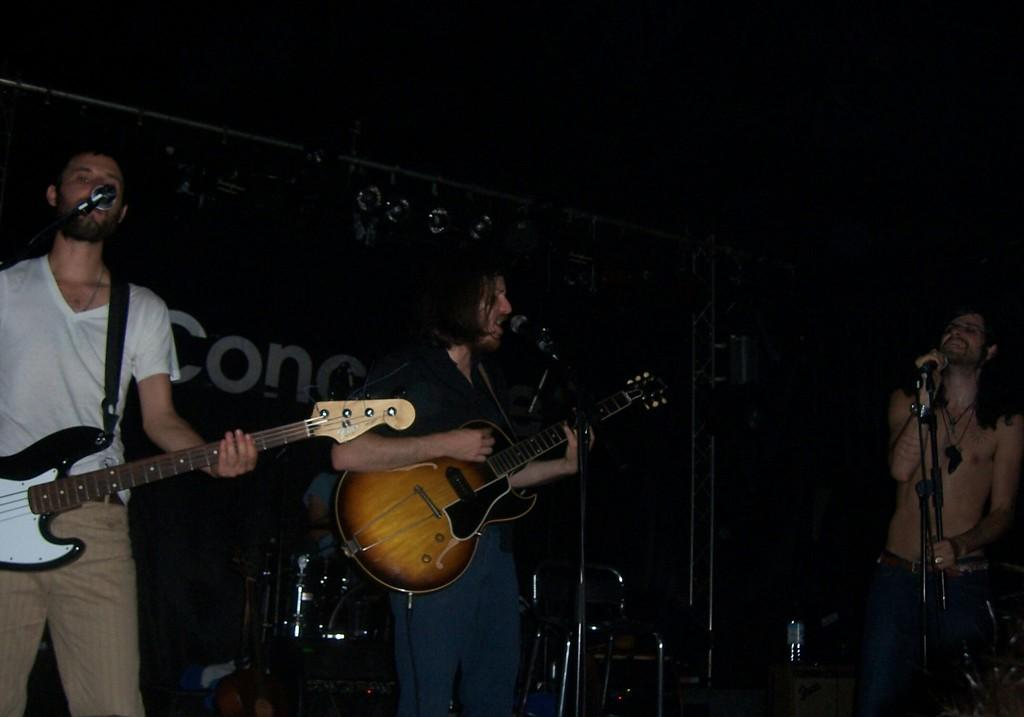What are the two men in the image doing? The two men are playing the guitar. Is there anyone else involved in the musical activity? Yes, one person is singing. What type of event is taking place in the image? The setting is a musical concert. How many trains can be seen in the image? There are no trains visible in the image. What is the price of the drum being played in the image? There is no drum present in the image. 